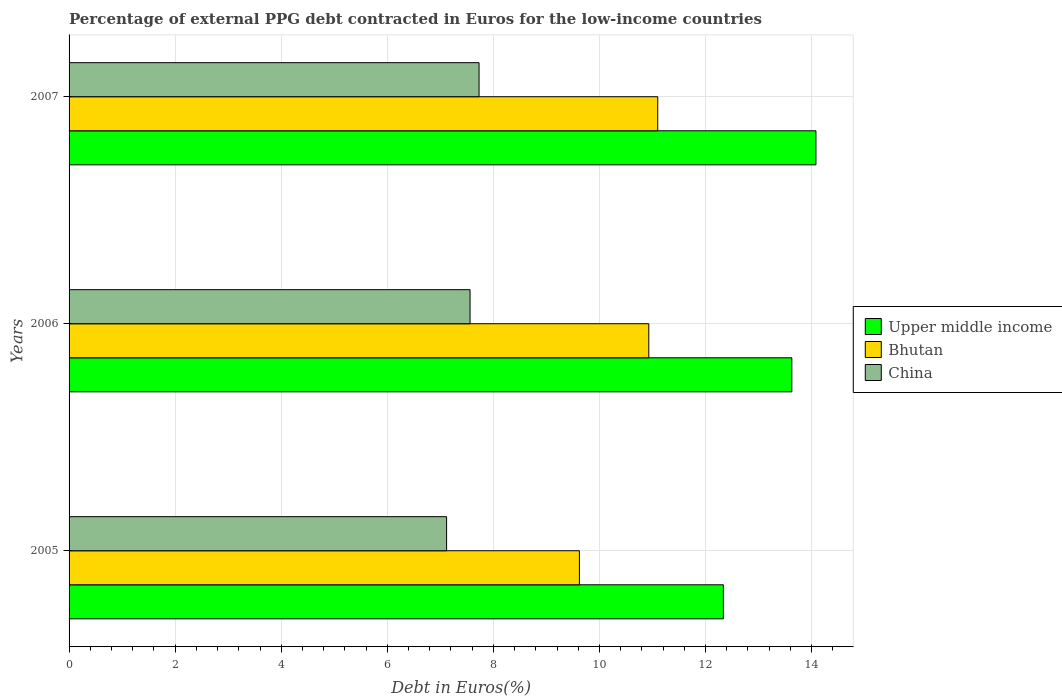Are the number of bars per tick equal to the number of legend labels?
Provide a succinct answer. Yes. Are the number of bars on each tick of the Y-axis equal?
Your answer should be compact. Yes. How many bars are there on the 1st tick from the top?
Your answer should be compact. 3. How many bars are there on the 2nd tick from the bottom?
Provide a short and direct response. 3. What is the label of the 1st group of bars from the top?
Your response must be concise. 2007. What is the percentage of external PPG debt contracted in Euros in Upper middle income in 2007?
Your answer should be very brief. 14.08. Across all years, what is the maximum percentage of external PPG debt contracted in Euros in Bhutan?
Ensure brevity in your answer.  11.1. Across all years, what is the minimum percentage of external PPG debt contracted in Euros in Upper middle income?
Ensure brevity in your answer.  12.34. In which year was the percentage of external PPG debt contracted in Euros in Bhutan maximum?
Offer a very short reply. 2007. In which year was the percentage of external PPG debt contracted in Euros in China minimum?
Provide a succinct answer. 2005. What is the total percentage of external PPG debt contracted in Euros in China in the graph?
Provide a short and direct response. 22.41. What is the difference between the percentage of external PPG debt contracted in Euros in China in 2005 and that in 2007?
Provide a succinct answer. -0.61. What is the difference between the percentage of external PPG debt contracted in Euros in China in 2005 and the percentage of external PPG debt contracted in Euros in Upper middle income in 2007?
Ensure brevity in your answer.  -6.96. What is the average percentage of external PPG debt contracted in Euros in China per year?
Provide a succinct answer. 7.47. In the year 2006, what is the difference between the percentage of external PPG debt contracted in Euros in China and percentage of external PPG debt contracted in Euros in Bhutan?
Your answer should be compact. -3.37. What is the ratio of the percentage of external PPG debt contracted in Euros in Upper middle income in 2005 to that in 2007?
Offer a terse response. 0.88. Is the percentage of external PPG debt contracted in Euros in China in 2005 less than that in 2007?
Ensure brevity in your answer.  Yes. Is the difference between the percentage of external PPG debt contracted in Euros in China in 2005 and 2006 greater than the difference between the percentage of external PPG debt contracted in Euros in Bhutan in 2005 and 2006?
Offer a very short reply. Yes. What is the difference between the highest and the second highest percentage of external PPG debt contracted in Euros in China?
Your answer should be compact. 0.17. What is the difference between the highest and the lowest percentage of external PPG debt contracted in Euros in China?
Offer a terse response. 0.61. In how many years, is the percentage of external PPG debt contracted in Euros in Upper middle income greater than the average percentage of external PPG debt contracted in Euros in Upper middle income taken over all years?
Keep it short and to the point. 2. Is the sum of the percentage of external PPG debt contracted in Euros in Upper middle income in 2005 and 2007 greater than the maximum percentage of external PPG debt contracted in Euros in Bhutan across all years?
Keep it short and to the point. Yes. What does the 2nd bar from the top in 2006 represents?
Your response must be concise. Bhutan. What does the 2nd bar from the bottom in 2005 represents?
Provide a succinct answer. Bhutan. How many years are there in the graph?
Give a very brief answer. 3. What is the difference between two consecutive major ticks on the X-axis?
Offer a very short reply. 2. Where does the legend appear in the graph?
Your answer should be very brief. Center right. How many legend labels are there?
Your answer should be very brief. 3. What is the title of the graph?
Offer a terse response. Percentage of external PPG debt contracted in Euros for the low-income countries. Does "Gabon" appear as one of the legend labels in the graph?
Provide a succinct answer. No. What is the label or title of the X-axis?
Provide a short and direct response. Debt in Euros(%). What is the Debt in Euros(%) of Upper middle income in 2005?
Offer a terse response. 12.34. What is the Debt in Euros(%) of Bhutan in 2005?
Your response must be concise. 9.62. What is the Debt in Euros(%) in China in 2005?
Give a very brief answer. 7.12. What is the Debt in Euros(%) in Upper middle income in 2006?
Your answer should be very brief. 13.63. What is the Debt in Euros(%) in Bhutan in 2006?
Give a very brief answer. 10.93. What is the Debt in Euros(%) of China in 2006?
Your response must be concise. 7.56. What is the Debt in Euros(%) in Upper middle income in 2007?
Ensure brevity in your answer.  14.08. What is the Debt in Euros(%) in Bhutan in 2007?
Give a very brief answer. 11.1. What is the Debt in Euros(%) of China in 2007?
Offer a very short reply. 7.73. Across all years, what is the maximum Debt in Euros(%) of Upper middle income?
Your answer should be very brief. 14.08. Across all years, what is the maximum Debt in Euros(%) of Bhutan?
Offer a very short reply. 11.1. Across all years, what is the maximum Debt in Euros(%) in China?
Provide a short and direct response. 7.73. Across all years, what is the minimum Debt in Euros(%) in Upper middle income?
Provide a short and direct response. 12.34. Across all years, what is the minimum Debt in Euros(%) of Bhutan?
Provide a succinct answer. 9.62. Across all years, what is the minimum Debt in Euros(%) in China?
Your response must be concise. 7.12. What is the total Debt in Euros(%) in Upper middle income in the graph?
Provide a short and direct response. 40.04. What is the total Debt in Euros(%) in Bhutan in the graph?
Your response must be concise. 31.65. What is the total Debt in Euros(%) of China in the graph?
Provide a succinct answer. 22.41. What is the difference between the Debt in Euros(%) in Upper middle income in 2005 and that in 2006?
Provide a succinct answer. -1.29. What is the difference between the Debt in Euros(%) of Bhutan in 2005 and that in 2006?
Ensure brevity in your answer.  -1.31. What is the difference between the Debt in Euros(%) in China in 2005 and that in 2006?
Offer a terse response. -0.44. What is the difference between the Debt in Euros(%) in Upper middle income in 2005 and that in 2007?
Give a very brief answer. -1.74. What is the difference between the Debt in Euros(%) in Bhutan in 2005 and that in 2007?
Offer a very short reply. -1.48. What is the difference between the Debt in Euros(%) in China in 2005 and that in 2007?
Keep it short and to the point. -0.61. What is the difference between the Debt in Euros(%) in Upper middle income in 2006 and that in 2007?
Keep it short and to the point. -0.45. What is the difference between the Debt in Euros(%) in Bhutan in 2006 and that in 2007?
Offer a terse response. -0.17. What is the difference between the Debt in Euros(%) of China in 2006 and that in 2007?
Your response must be concise. -0.17. What is the difference between the Debt in Euros(%) in Upper middle income in 2005 and the Debt in Euros(%) in Bhutan in 2006?
Your answer should be compact. 1.41. What is the difference between the Debt in Euros(%) in Upper middle income in 2005 and the Debt in Euros(%) in China in 2006?
Offer a terse response. 4.78. What is the difference between the Debt in Euros(%) of Bhutan in 2005 and the Debt in Euros(%) of China in 2006?
Offer a terse response. 2.06. What is the difference between the Debt in Euros(%) of Upper middle income in 2005 and the Debt in Euros(%) of Bhutan in 2007?
Offer a terse response. 1.24. What is the difference between the Debt in Euros(%) of Upper middle income in 2005 and the Debt in Euros(%) of China in 2007?
Keep it short and to the point. 4.61. What is the difference between the Debt in Euros(%) of Bhutan in 2005 and the Debt in Euros(%) of China in 2007?
Keep it short and to the point. 1.89. What is the difference between the Debt in Euros(%) of Upper middle income in 2006 and the Debt in Euros(%) of Bhutan in 2007?
Ensure brevity in your answer.  2.53. What is the difference between the Debt in Euros(%) in Upper middle income in 2006 and the Debt in Euros(%) in China in 2007?
Ensure brevity in your answer.  5.9. What is the difference between the Debt in Euros(%) of Bhutan in 2006 and the Debt in Euros(%) of China in 2007?
Offer a terse response. 3.2. What is the average Debt in Euros(%) of Upper middle income per year?
Make the answer very short. 13.35. What is the average Debt in Euros(%) of Bhutan per year?
Ensure brevity in your answer.  10.55. What is the average Debt in Euros(%) in China per year?
Offer a terse response. 7.47. In the year 2005, what is the difference between the Debt in Euros(%) of Upper middle income and Debt in Euros(%) of Bhutan?
Provide a short and direct response. 2.71. In the year 2005, what is the difference between the Debt in Euros(%) of Upper middle income and Debt in Euros(%) of China?
Your answer should be compact. 5.22. In the year 2005, what is the difference between the Debt in Euros(%) of Bhutan and Debt in Euros(%) of China?
Your response must be concise. 2.5. In the year 2006, what is the difference between the Debt in Euros(%) of Upper middle income and Debt in Euros(%) of Bhutan?
Your response must be concise. 2.7. In the year 2006, what is the difference between the Debt in Euros(%) of Upper middle income and Debt in Euros(%) of China?
Offer a very short reply. 6.07. In the year 2006, what is the difference between the Debt in Euros(%) of Bhutan and Debt in Euros(%) of China?
Provide a succinct answer. 3.37. In the year 2007, what is the difference between the Debt in Euros(%) of Upper middle income and Debt in Euros(%) of Bhutan?
Provide a succinct answer. 2.98. In the year 2007, what is the difference between the Debt in Euros(%) of Upper middle income and Debt in Euros(%) of China?
Your response must be concise. 6.35. In the year 2007, what is the difference between the Debt in Euros(%) in Bhutan and Debt in Euros(%) in China?
Provide a succinct answer. 3.37. What is the ratio of the Debt in Euros(%) of Upper middle income in 2005 to that in 2006?
Your answer should be compact. 0.91. What is the ratio of the Debt in Euros(%) in Bhutan in 2005 to that in 2006?
Your answer should be very brief. 0.88. What is the ratio of the Debt in Euros(%) of China in 2005 to that in 2006?
Keep it short and to the point. 0.94. What is the ratio of the Debt in Euros(%) of Upper middle income in 2005 to that in 2007?
Your answer should be compact. 0.88. What is the ratio of the Debt in Euros(%) of Bhutan in 2005 to that in 2007?
Your answer should be compact. 0.87. What is the ratio of the Debt in Euros(%) in China in 2005 to that in 2007?
Provide a succinct answer. 0.92. What is the ratio of the Debt in Euros(%) in Upper middle income in 2006 to that in 2007?
Provide a succinct answer. 0.97. What is the ratio of the Debt in Euros(%) in China in 2006 to that in 2007?
Your answer should be very brief. 0.98. What is the difference between the highest and the second highest Debt in Euros(%) in Upper middle income?
Your answer should be compact. 0.45. What is the difference between the highest and the second highest Debt in Euros(%) in Bhutan?
Offer a very short reply. 0.17. What is the difference between the highest and the second highest Debt in Euros(%) of China?
Your answer should be very brief. 0.17. What is the difference between the highest and the lowest Debt in Euros(%) of Upper middle income?
Your answer should be compact. 1.74. What is the difference between the highest and the lowest Debt in Euros(%) in Bhutan?
Provide a succinct answer. 1.48. What is the difference between the highest and the lowest Debt in Euros(%) of China?
Provide a succinct answer. 0.61. 